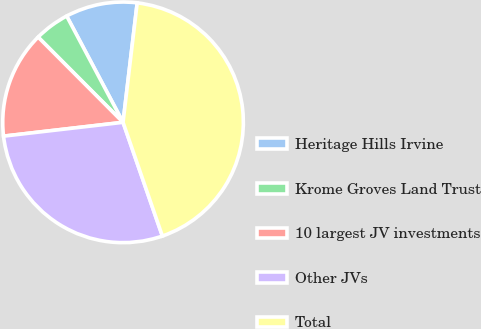Convert chart. <chart><loc_0><loc_0><loc_500><loc_500><pie_chart><fcel>Heritage Hills Irvine<fcel>Krome Groves Land Trust<fcel>10 largest JV investments<fcel>Other JVs<fcel>Total<nl><fcel>9.64%<fcel>4.71%<fcel>14.36%<fcel>28.47%<fcel>42.82%<nl></chart> 